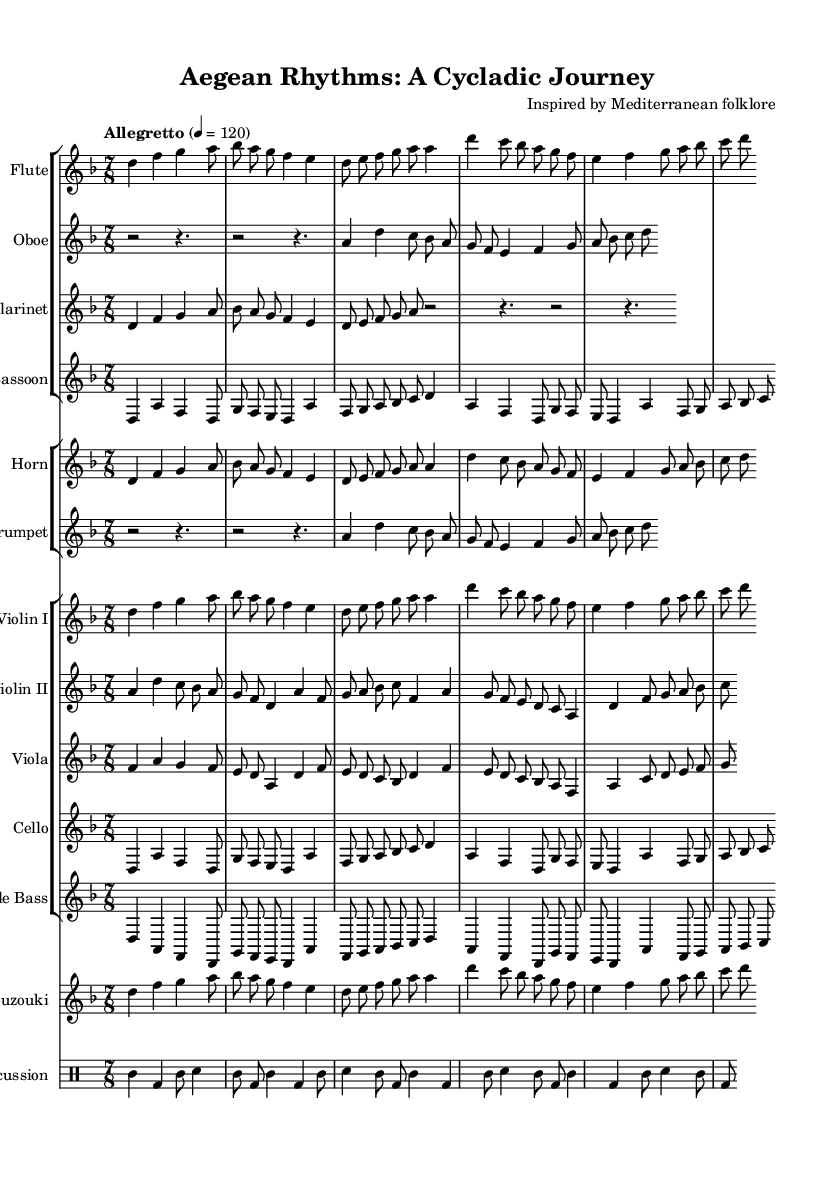What is the key signature of this music? The key signature indicates D minor, which is represented by one flat (B flat) when looking at the key signature at the beginning of the staff.
Answer: D minor What is the time signature of the piece? The time signature at the beginning of the score is 7/8, which shows there are 7 beats in a measure, and the eighth note receives one beat.
Answer: 7/8 What is the tempo marking indicated in the music? The tempo marking clearly states "Allegretto" with a metronome marking of 120, indicating a moderately fast speed.
Answer: Allegretto, 120 Which instrument has a specific notation for being in a different key? The clarinet and trumpet are notated with "transposition" indicating they will read music that sounds different than it is written, thus clarinet is in B flat.
Answer: Clarinet How many different instrument groups are present in this score? The score includes four groups: woodwinds, brass, strings, and percussion; each group contains various instruments contributing to the overall orchestral sound.
Answer: Four What unique instrument reminiscent of Greek culture is included in the ensemble? The presence of the bouzouki is notable, a string instrument commonly associated with Greek music and culture, adding to the Mediterranean flavor of the suite.
Answer: Bouzouki 